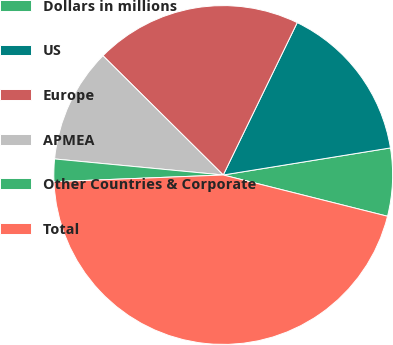Convert chart to OTSL. <chart><loc_0><loc_0><loc_500><loc_500><pie_chart><fcel>Dollars in millions<fcel>US<fcel>Europe<fcel>APMEA<fcel>Other Countries & Corporate<fcel>Total<nl><fcel>6.47%<fcel>15.25%<fcel>19.76%<fcel>10.92%<fcel>2.14%<fcel>45.45%<nl></chart> 